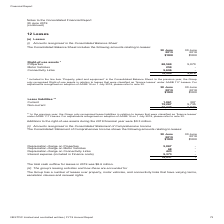From Nextdc's financial document, What costs are taken into account for measuring Right-of-use assets? The document contains multiple relevant values: the amount of the initial measurement of lease liability, any lease payments made at or before the commencement date, less any lease incentives received, any initial direct costs, restoration costs. Also, How much was the additions to the right-of-use assets during FY19? According to the financial document, $0.3 million.. The relevant text states: "-of-use assets during the 2019 financial year were $0.3 million...." Also, How much value of right-of-use assets in relation to leases are recognised by the Group? According to the financial document, 78,524 (in thousands). The relevant text states: "78,524 5,070..." Additionally, Which year has the higher total right-of-use assets? According to the financial document, 2019. The relevant text states: "otes to the Consolidated Financial Report 30 June 2019 (continued)..." Also, can you calculate: What was the percentage change in values of properties between 2018 and 2019? To answer this question, I need to perform calculations using the financial data. The calculation is: (68,569 - 5,070) / 5,070 , which equals 1252.45 (percentage). This is based on the information: "Right-of-use assets * Properties 68,569 5,070 Motor Vehicles 259 - Connectivity Links 9,696 - Right-of-use assets * Properties 68,569 5,070 Motor Vehicles 259 - Connectivity Links 9,696 -..." The key data points involved are: 5,070, 68,569. Also, can you calculate: What was the sum of values of motor vehicles and connectivity links in 2019? Based on the calculation: 259 + 9,696 , the result is 9955 (in thousands). This is based on the information: "569 5,070 Motor Vehicles 259 - Connectivity Links 9,696 - e assets * Properties 68,569 5,070 Motor Vehicles 259 - Connectivity Links 9,696 -..." The key data points involved are: 259, 9,696. 